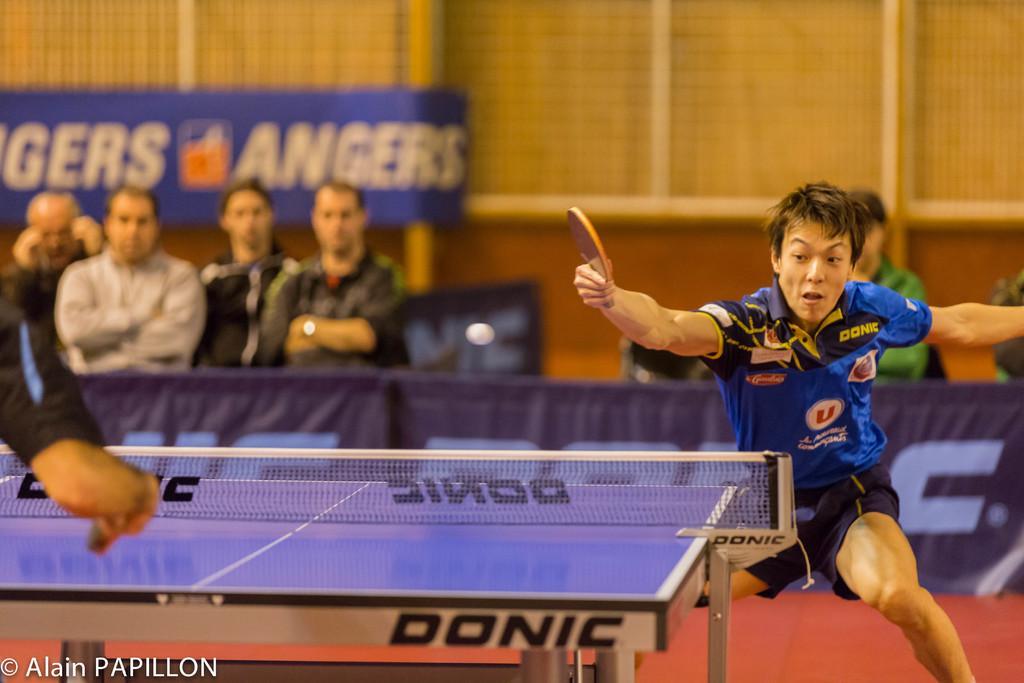In one or two sentences, can you explain what this image depicts? This is a table tennis board. This is a net. He is a man holding who is holding a bat in his hands. There are a four people on the left side watching a game. 